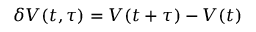<formula> <loc_0><loc_0><loc_500><loc_500>\delta V ( t , \tau ) = V ( t + \tau ) - V ( t )</formula> 